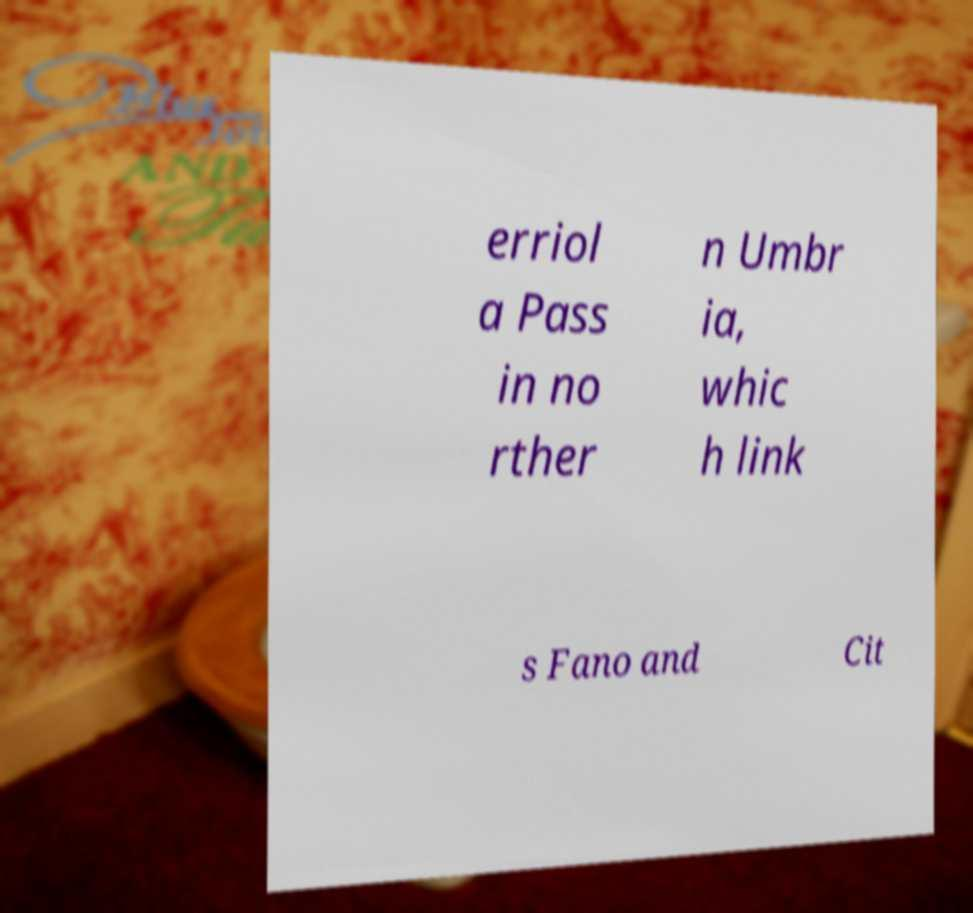Please read and relay the text visible in this image. What does it say? erriol a Pass in no rther n Umbr ia, whic h link s Fano and Cit 